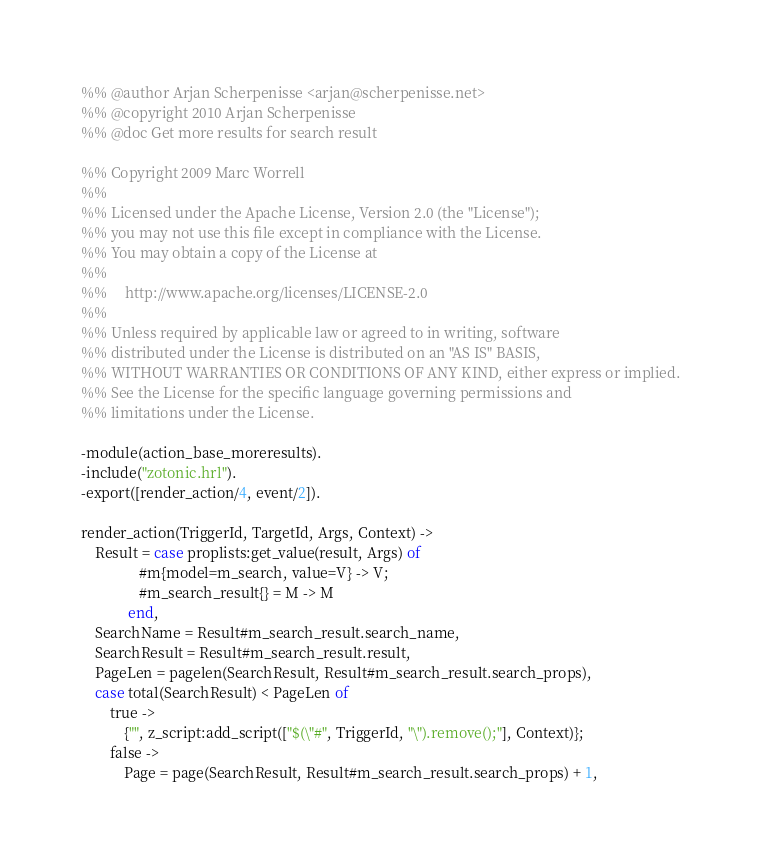Convert code to text. <code><loc_0><loc_0><loc_500><loc_500><_Erlang_>%% @author Arjan Scherpenisse <arjan@scherpenisse.net>
%% @copyright 2010 Arjan Scherpenisse
%% @doc Get more results for search result

%% Copyright 2009 Marc Worrell
%%
%% Licensed under the Apache License, Version 2.0 (the "License");
%% you may not use this file except in compliance with the License.
%% You may obtain a copy of the License at
%%
%%     http://www.apache.org/licenses/LICENSE-2.0
%%
%% Unless required by applicable law or agreed to in writing, software
%% distributed under the License is distributed on an "AS IS" BASIS,
%% WITHOUT WARRANTIES OR CONDITIONS OF ANY KIND, either express or implied.
%% See the License for the specific language governing permissions and
%% limitations under the License.

-module(action_base_moreresults).
-include("zotonic.hrl").
-export([render_action/4, event/2]).

render_action(TriggerId, TargetId, Args, Context) ->
    Result = case proplists:get_value(result, Args) of
                #m{model=m_search, value=V} -> V;
                #m_search_result{} = M -> M
             end,
    SearchName = Result#m_search_result.search_name,
    SearchResult = Result#m_search_result.result,
    PageLen = pagelen(SearchResult, Result#m_search_result.search_props),
    case total(SearchResult) < PageLen of
        true ->
            {"", z_script:add_script(["$(\"#", TriggerId, "\").remove();"], Context)};
        false ->
            Page = page(SearchResult, Result#m_search_result.search_props) + 1,</code> 